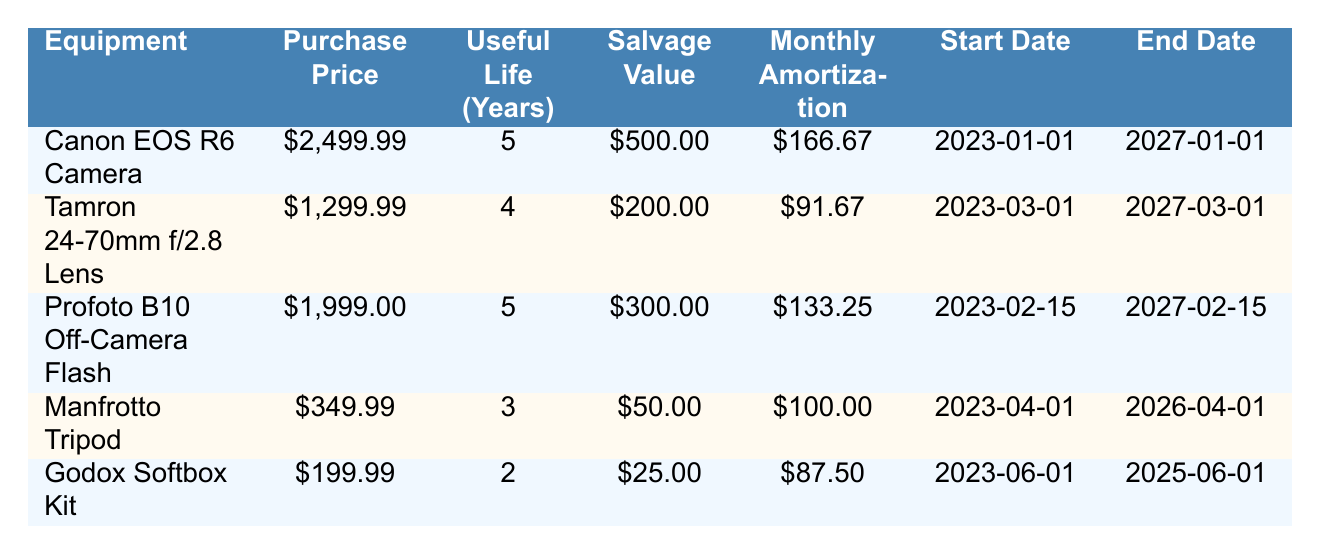What is the purchase price of the Canon EOS R6 Camera? The purchase price is listed in the relevant row of the table where the equipment is the Canon EOS R6 Camera. It reads $2,499.99.
Answer: 2499.99 How long is the useful life of the Godox Softbox Kit? The useful life can be found in the row corresponding to the Godox Softbox Kit in the table. It indicates 2 years.
Answer: 2 What is the total monthly amortization for all equipment? To find the total, sum the monthly amortization values for all items: 166.67 + 91.67 + 133.25 + 100.00 + 87.50 = 579.09.
Answer: 579.09 Is the salvage value of the Manfrotto Tripod greater than $50? In the table, the salvage value for the Manfrotto Tripod is marked at $50, therefore the statement is false since it is not greater than $50.
Answer: No Which equipment has the longest useful life, and how many years is that? By examining the useful life entries across all equipment, the Canon EOS R6 Camera, Profoto B10 Off-Camera Flash, and Tamron 24-70mm f/2.8 Lens all have the longest useful life of 5 years.
Answer: Canon EOS R6 Camera, 5 years What is the total purchase price of the items with a useful life of 5 years? First, identify the items with a 5-year life: Canon EOS R6 Camera ($2499.99) and Profoto B10 Off-Camera Flash ($1999.00). Now adding them gives $2499.99 + $1999.00 = $4498.99.
Answer: 4498.99 Does the Tamron 24-70mm f/2.8 Lens have a monthly amortization higher than $100? The monthly amortization for the Tamron 24-70mm f/2.8 Lens is $91.67, which is less than $100. Thus, the answer is false.
Answer: No What is the salvage value of the Profoto B10 Off-Camera Flash and how does it compare to the Godox Softbox Kit? The salvage value of the Profoto B10 Off-Camera Flash is $300. The Godox Softbox Kit has a salvage value of $25. Comparing the two shows that $300 is greater than $25.
Answer: 300, greater What is the difference in monthly amortization between the Canon EOS R6 Camera and the Manfrotto Tripod? The monthly amortization for the Canon EOS R6 Camera is $166.67 and for the Manfrotto Tripod, it's $100. The difference is $166.67 - $100 = $66.67.
Answer: 66.67 